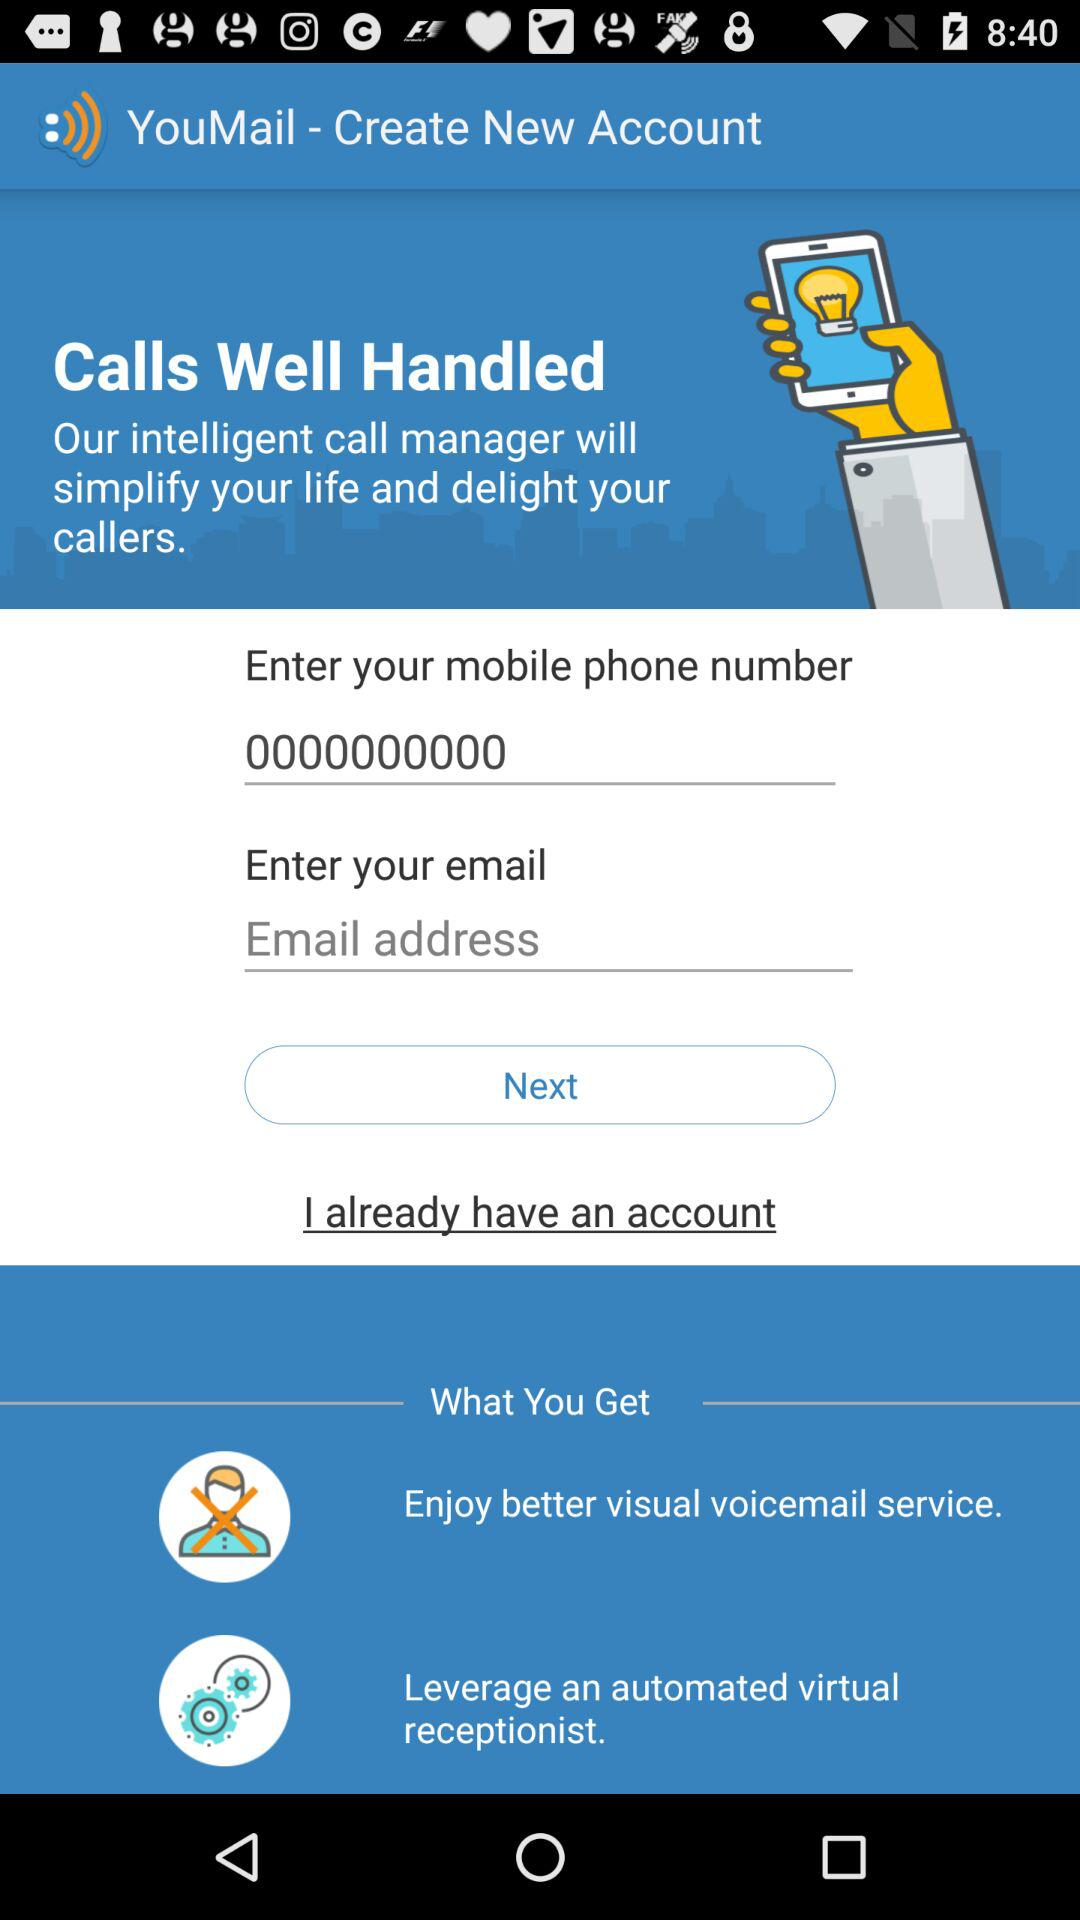What is the mobile number? The mobile number is 0000000000. 